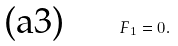<formula> <loc_0><loc_0><loc_500><loc_500>\text {(a3)\quad \ \ } F _ { 1 } = 0 .</formula> 